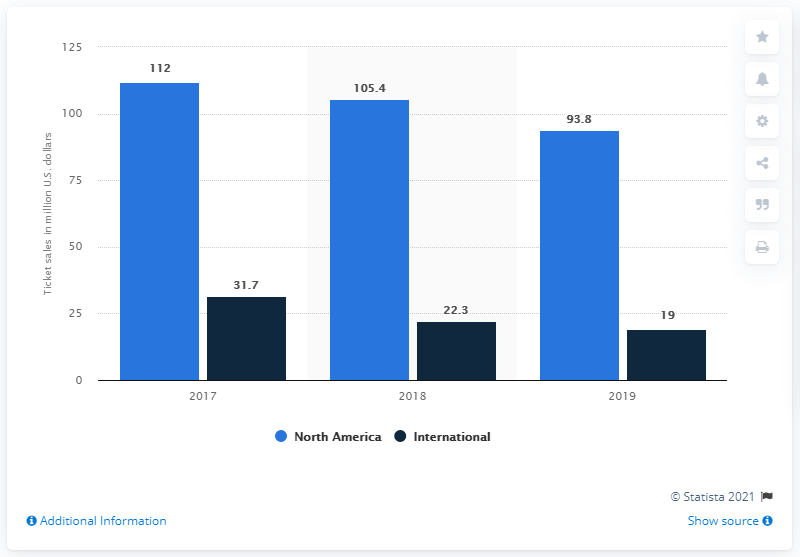Point out several critical features in this image. In 2019, World Wrestling Entertainment reported ticket sales revenue of 93.8 million dollars in North America. 